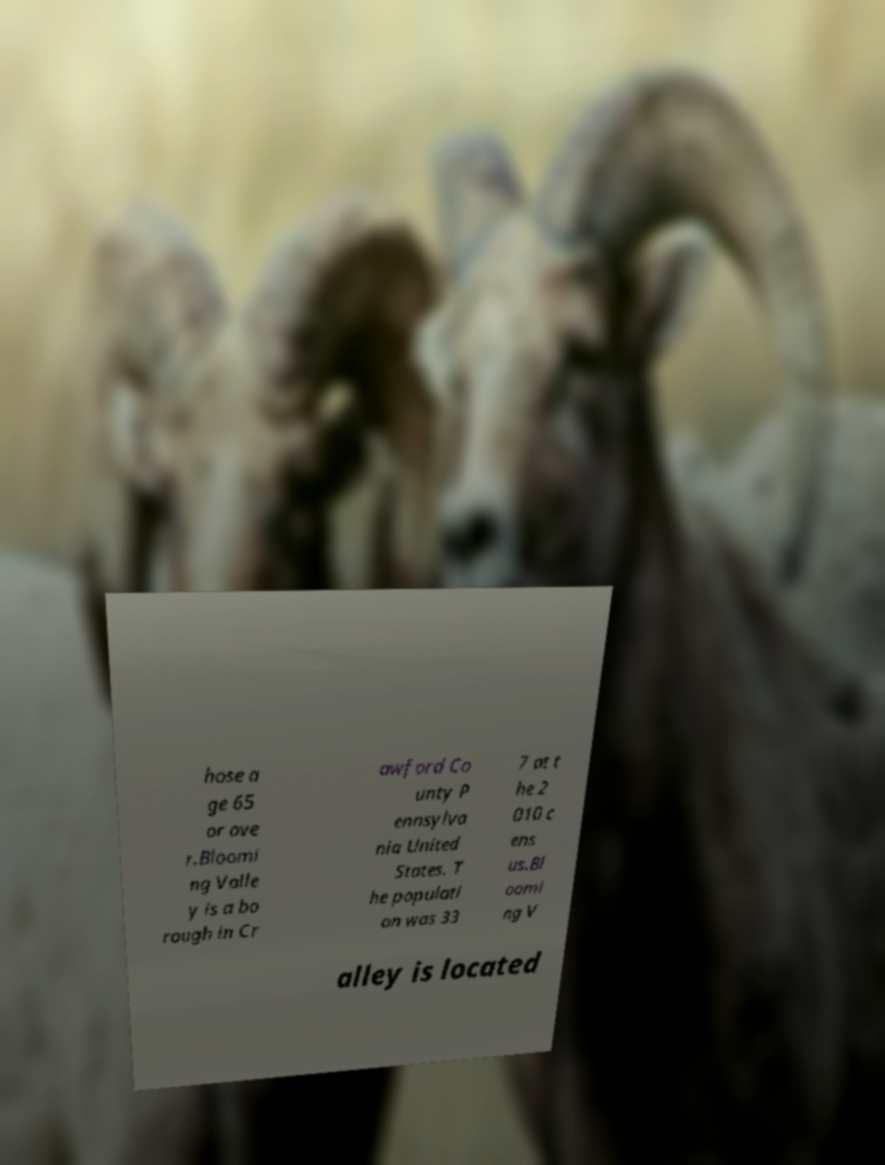For documentation purposes, I need the text within this image transcribed. Could you provide that? hose a ge 65 or ove r.Bloomi ng Valle y is a bo rough in Cr awford Co unty P ennsylva nia United States. T he populati on was 33 7 at t he 2 010 c ens us.Bl oomi ng V alley is located 